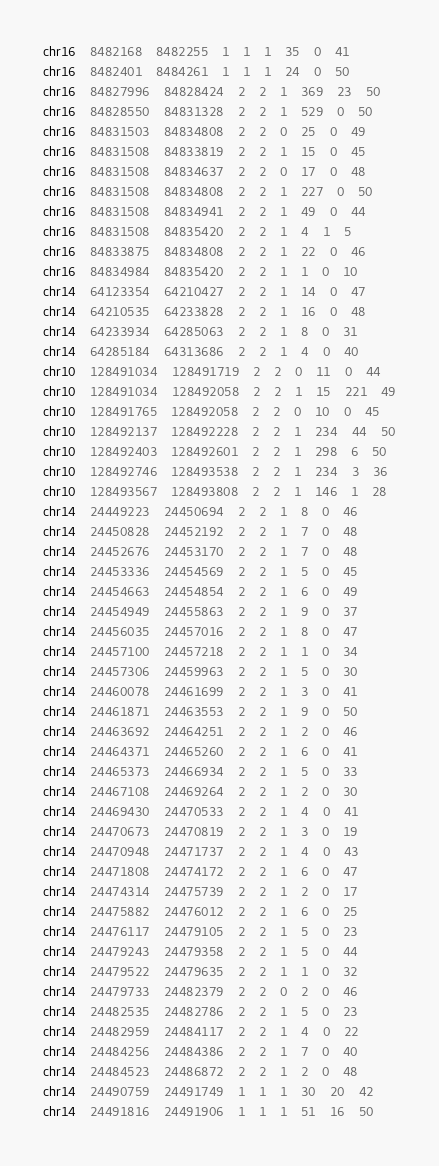<code> <loc_0><loc_0><loc_500><loc_500><_SQL_>chr16	8482168	8482255	1	1	1	35	0	41
chr16	8482401	8484261	1	1	1	24	0	50
chr16	84827996	84828424	2	2	1	369	23	50
chr16	84828550	84831328	2	2	1	529	0	50
chr16	84831503	84834808	2	2	0	25	0	49
chr16	84831508	84833819	2	2	1	15	0	45
chr16	84831508	84834637	2	2	0	17	0	48
chr16	84831508	84834808	2	2	1	227	0	50
chr16	84831508	84834941	2	2	1	49	0	44
chr16	84831508	84835420	2	2	1	4	1	5
chr16	84833875	84834808	2	2	1	22	0	46
chr16	84834984	84835420	2	2	1	1	0	10
chr14	64123354	64210427	2	2	1	14	0	47
chr14	64210535	64233828	2	2	1	16	0	48
chr14	64233934	64285063	2	2	1	8	0	31
chr14	64285184	64313686	2	2	1	4	0	40
chr10	128491034	128491719	2	2	0	11	0	44
chr10	128491034	128492058	2	2	1	15	221	49
chr10	128491765	128492058	2	2	0	10	0	45
chr10	128492137	128492228	2	2	1	234	44	50
chr10	128492403	128492601	2	2	1	298	6	50
chr10	128492746	128493538	2	2	1	234	3	36
chr10	128493567	128493808	2	2	1	146	1	28
chr14	24449223	24450694	2	2	1	8	0	46
chr14	24450828	24452192	2	2	1	7	0	48
chr14	24452676	24453170	2	2	1	7	0	48
chr14	24453336	24454569	2	2	1	5	0	45
chr14	24454663	24454854	2	2	1	6	0	49
chr14	24454949	24455863	2	2	1	9	0	37
chr14	24456035	24457016	2	2	1	8	0	47
chr14	24457100	24457218	2	2	1	1	0	34
chr14	24457306	24459963	2	2	1	5	0	30
chr14	24460078	24461699	2	2	1	3	0	41
chr14	24461871	24463553	2	2	1	9	0	50
chr14	24463692	24464251	2	2	1	2	0	46
chr14	24464371	24465260	2	2	1	6	0	41
chr14	24465373	24466934	2	2	1	5	0	33
chr14	24467108	24469264	2	2	1	2	0	30
chr14	24469430	24470533	2	2	1	4	0	41
chr14	24470673	24470819	2	2	1	3	0	19
chr14	24470948	24471737	2	2	1	4	0	43
chr14	24471808	24474172	2	2	1	6	0	47
chr14	24474314	24475739	2	2	1	2	0	17
chr14	24475882	24476012	2	2	1	6	0	25
chr14	24476117	24479105	2	2	1	5	0	23
chr14	24479243	24479358	2	2	1	5	0	44
chr14	24479522	24479635	2	2	1	1	0	32
chr14	24479733	24482379	2	2	0	2	0	46
chr14	24482535	24482786	2	2	1	5	0	23
chr14	24482959	24484117	2	2	1	4	0	22
chr14	24484256	24484386	2	2	1	7	0	40
chr14	24484523	24486872	2	2	1	2	0	48
chr14	24490759	24491749	1	1	1	30	20	42
chr14	24491816	24491906	1	1	1	51	16	50</code> 